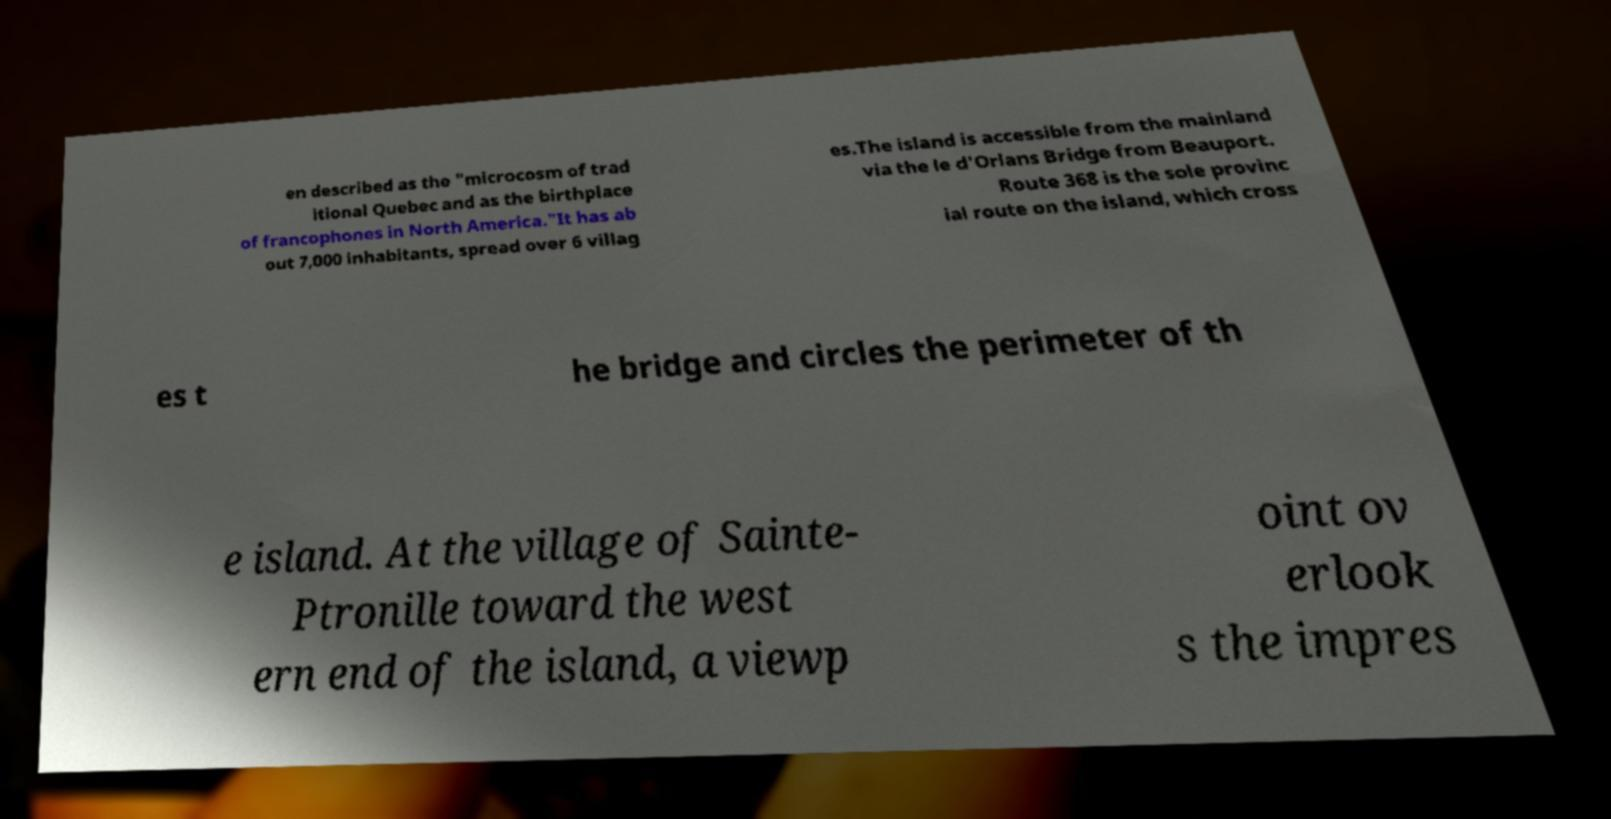There's text embedded in this image that I need extracted. Can you transcribe it verbatim? en described as the "microcosm of trad itional Quebec and as the birthplace of francophones in North America."It has ab out 7,000 inhabitants, spread over 6 villag es.The island is accessible from the mainland via the le d'Orlans Bridge from Beauport. Route 368 is the sole provinc ial route on the island, which cross es t he bridge and circles the perimeter of th e island. At the village of Sainte- Ptronille toward the west ern end of the island, a viewp oint ov erlook s the impres 